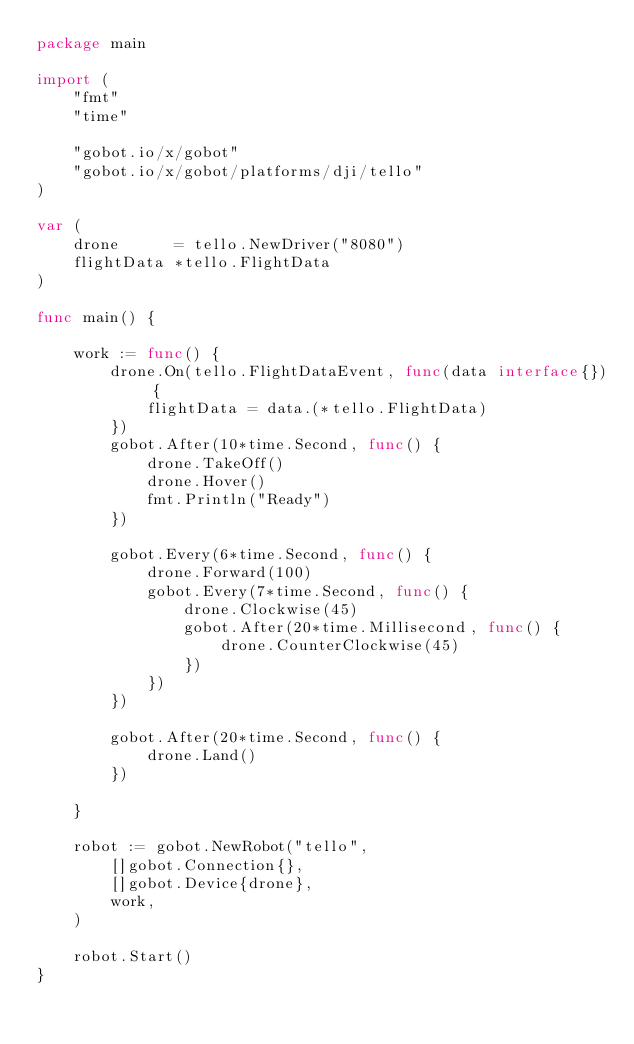Convert code to text. <code><loc_0><loc_0><loc_500><loc_500><_Go_>package main

import (
	"fmt"
	"time"

	"gobot.io/x/gobot"
	"gobot.io/x/gobot/platforms/dji/tello"
)

var (
	drone      = tello.NewDriver("8080")
	flightData *tello.FlightData
)

func main() {

	work := func() {
		drone.On(tello.FlightDataEvent, func(data interface{}) {
			flightData = data.(*tello.FlightData)
		})
		gobot.After(10*time.Second, func() {
			drone.TakeOff()
			drone.Hover()
			fmt.Println("Ready")
		})

		gobot.Every(6*time.Second, func() {
			drone.Forward(100)
			gobot.Every(7*time.Second, func() {
				drone.Clockwise(45)
				gobot.After(20*time.Millisecond, func() {
					drone.CounterClockwise(45)
				})
			})
		})

		gobot.After(20*time.Second, func() {
			drone.Land()
		})

	}

	robot := gobot.NewRobot("tello",
		[]gobot.Connection{},
		[]gobot.Device{drone},
		work,
	)

	robot.Start()
}</code> 